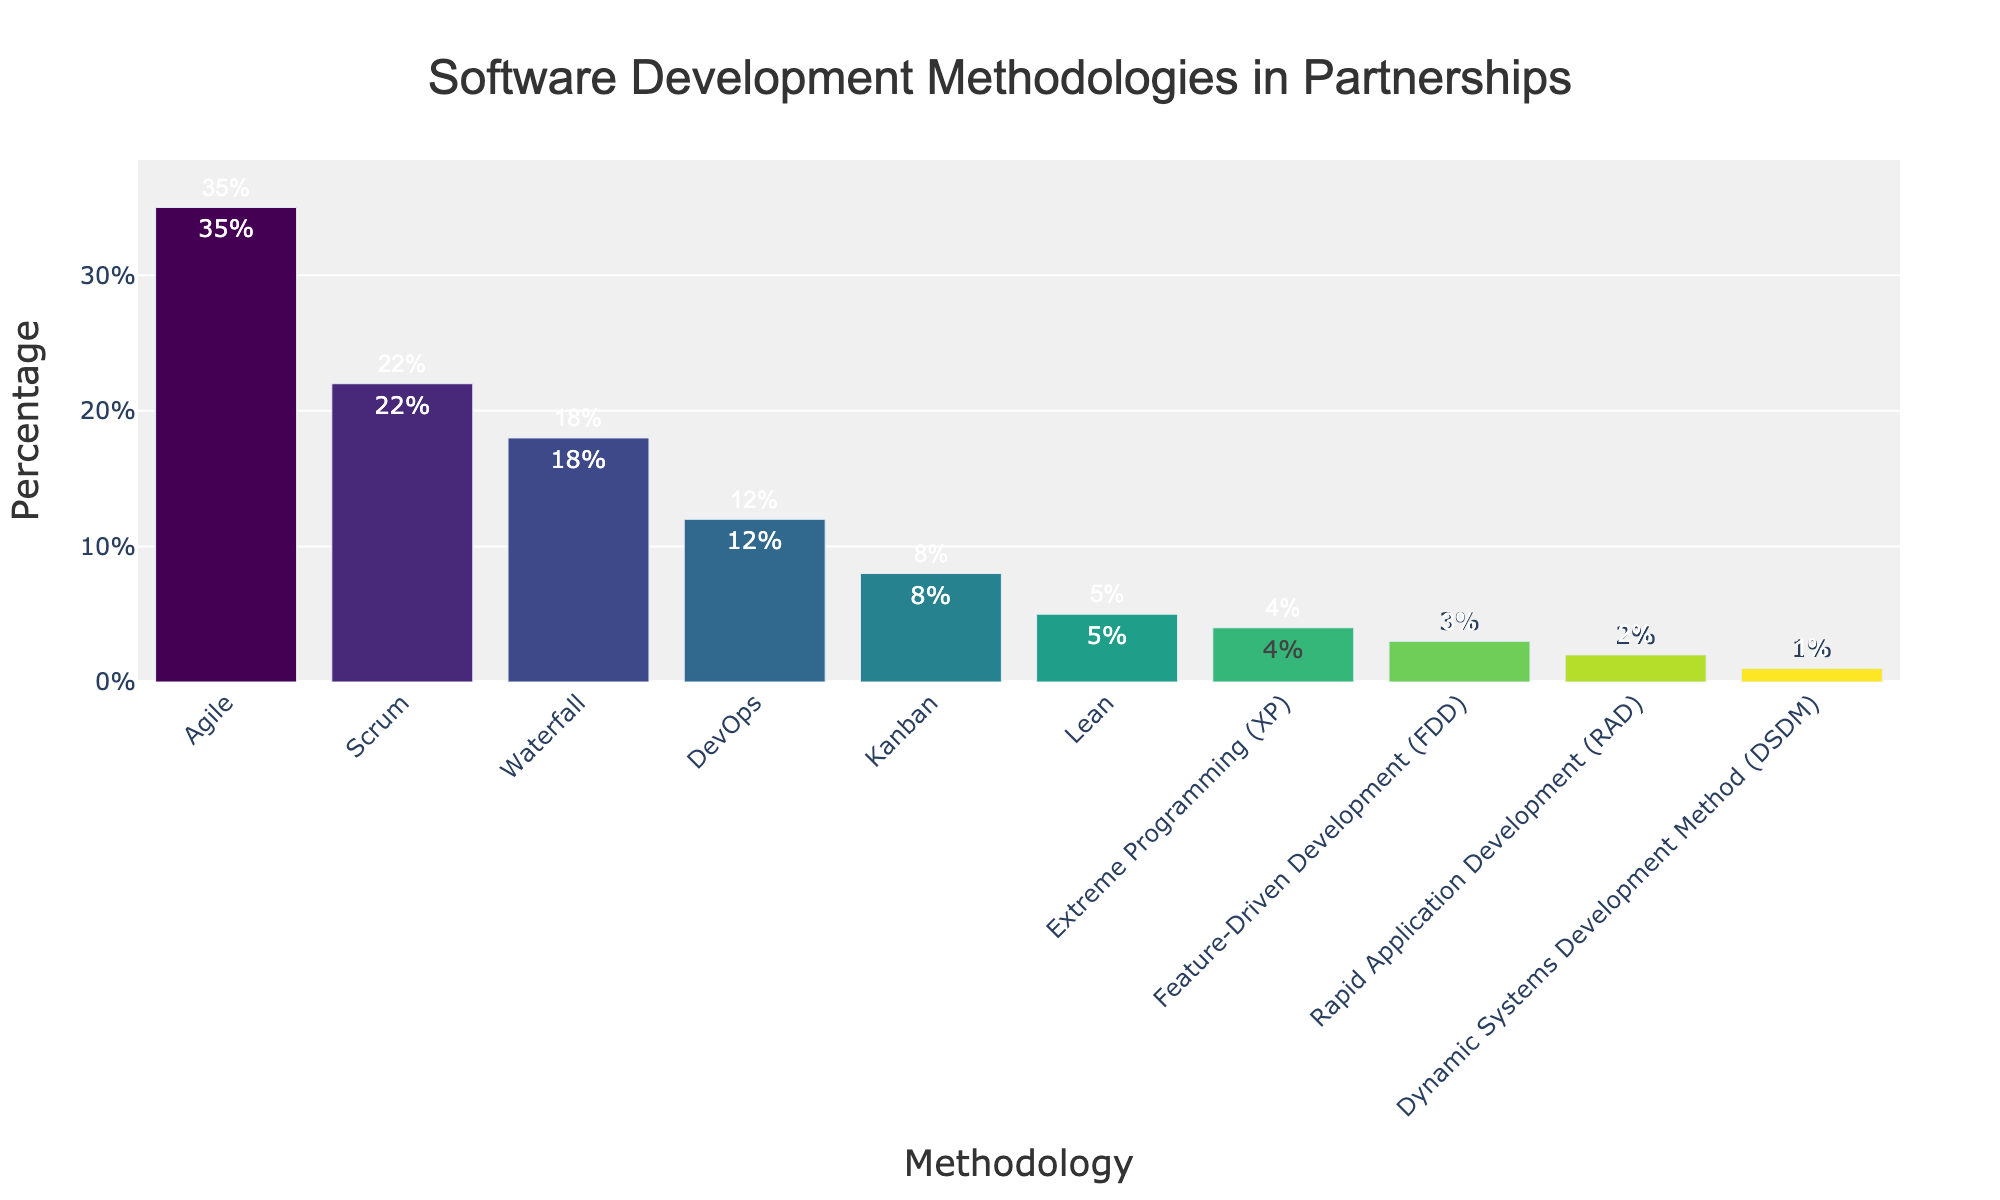What percentage of the projects use Agile methodology? Look at the bar corresponding to "Agile" and read the percentage value.
Answer: 35% Which two methodologies combined have a percentage of exactly 30%? Identify the two bars whose combined percentage equals 30%. "DevOps" and "Kanban" have percentages of 12% and 8%, respectively, which combined give 20%. Adding "Lean" (5%) results in 25%. After examining all combinations, "Scrum" (22%) and "Lean" (8%) combined make 30%.
Answer: Scrum and Kanban Which methodology is used least frequently in projects? Look for the shortest bar in the chart.
Answer: Dynamic Systems Development Method (DSDM) How many methodologies have a usage percentage of less than 10%? Count the number of bars whose percentage values are less than 10%.
Answer: 5 Which methodology is more popular, Waterfall or Scrum, and by how much? Compare the percentages of Waterfall (18%) and Scrum (22%). Calculate the difference.
Answer: Scrum is more popular by 4% How much greater is the percentage of projects using Agile compared to the total percentage of those using Lean, Extreme Programming (XP), and Feature-Driven Development (FDD) combined? Calculate the total percentage of Lean (5%), XP (4%), and FDD (3%) which is 5% + 4% + 3% = 12%. Then, find the difference between Agile (35%) and this combined value (12%).
Answer: 23% Which methodologies have a difference of 5% or more between them? Identify pairwise differences, such as Agile (35%) vs Waterfall (18%), which is 17%, Agile vs Scrum (22%) which is 13%, etc.
Answer: Agile vs Waterfall, Agile vs Scrum, Agile vs DevOps, etc What is the median percentage of the methodologies depicted in the chart? Arrange the percentages in ascending order: 1%, 2%, 3%, 4%, 5%, 8%, 12%, 18%, 22%, 35%. The median is the value in the middle, which is the 5th and 6th values: (8% + 12%) / 2.
Answer: 10% What percentage of methodologies have usage percentages greater than 12%? Count the number of bars with percentages greater than 12%: Agile (35%), Waterfall (18%), Scrum (22%). There are three out of ten.
Answer: 30% Which methodology has a percentage closest to but not exceeding 10%? Look for the methodology with the percentage closest to 10% without exceeding it. Kanban is 8%, just below 10%.
Answer: Kanban 